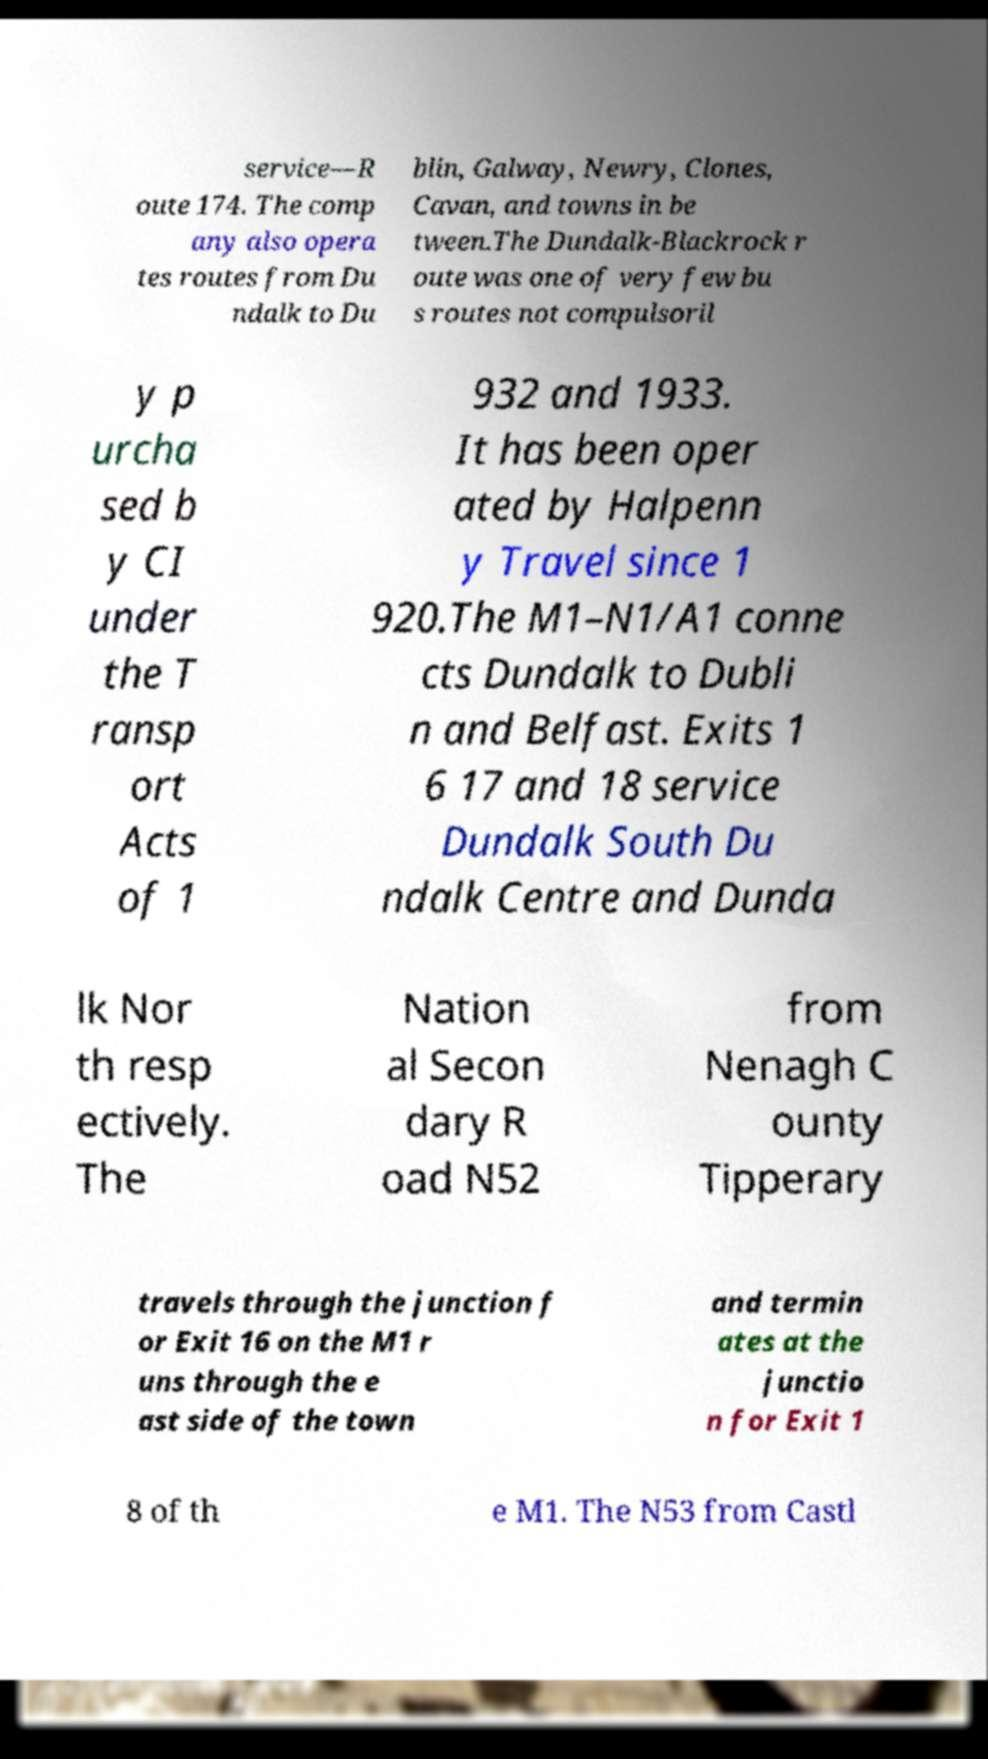Could you extract and type out the text from this image? service—R oute 174. The comp any also opera tes routes from Du ndalk to Du blin, Galway, Newry, Clones, Cavan, and towns in be tween.The Dundalk-Blackrock r oute was one of very few bu s routes not compulsoril y p urcha sed b y CI under the T ransp ort Acts of 1 932 and 1933. It has been oper ated by Halpenn y Travel since 1 920.The M1–N1/A1 conne cts Dundalk to Dubli n and Belfast. Exits 1 6 17 and 18 service Dundalk South Du ndalk Centre and Dunda lk Nor th resp ectively. The Nation al Secon dary R oad N52 from Nenagh C ounty Tipperary travels through the junction f or Exit 16 on the M1 r uns through the e ast side of the town and termin ates at the junctio n for Exit 1 8 of th e M1. The N53 from Castl 